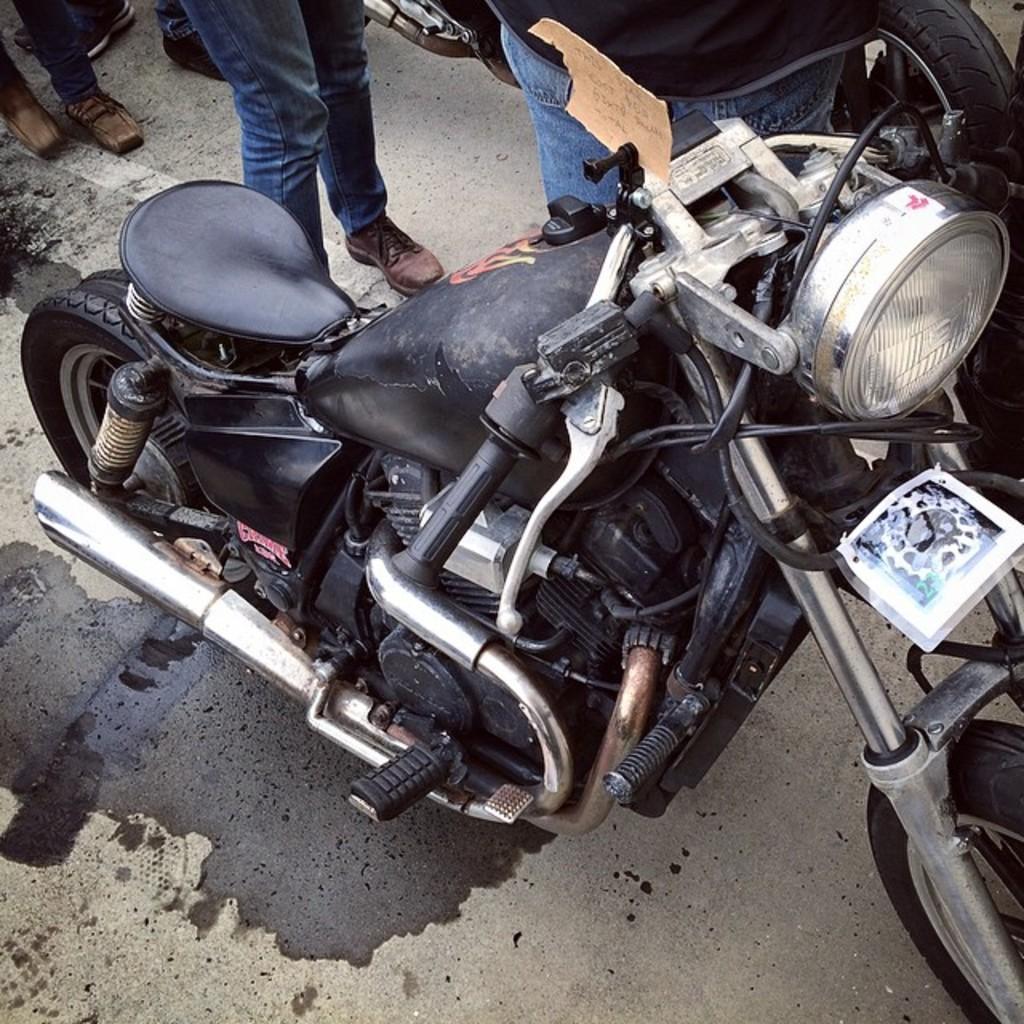Please provide a concise description of this image. In this image we can see a motorbike. In the background there are people. At the bottom there is a road. 